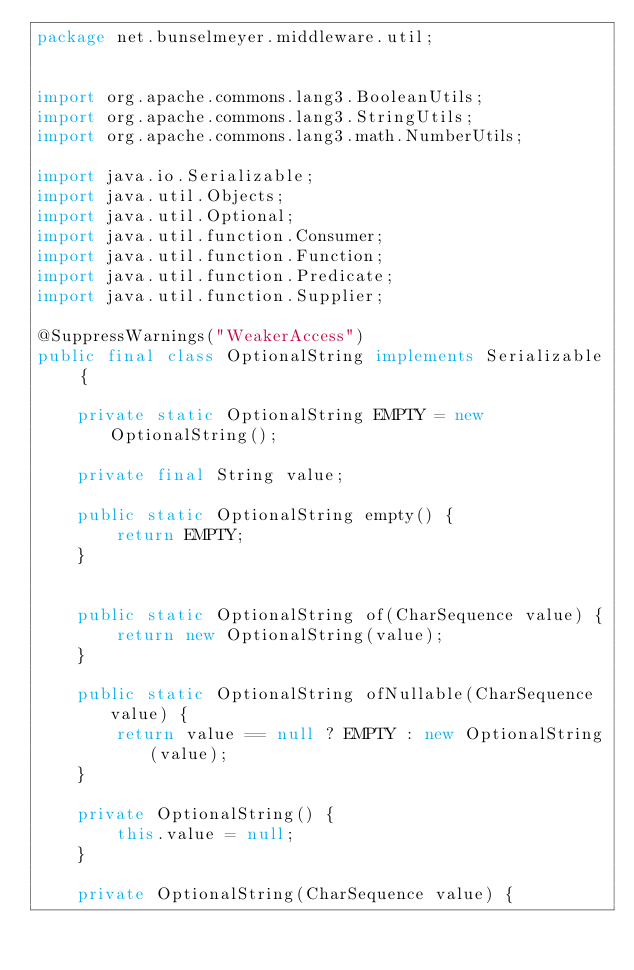<code> <loc_0><loc_0><loc_500><loc_500><_Java_>package net.bunselmeyer.middleware.util;


import org.apache.commons.lang3.BooleanUtils;
import org.apache.commons.lang3.StringUtils;
import org.apache.commons.lang3.math.NumberUtils;

import java.io.Serializable;
import java.util.Objects;
import java.util.Optional;
import java.util.function.Consumer;
import java.util.function.Function;
import java.util.function.Predicate;
import java.util.function.Supplier;

@SuppressWarnings("WeakerAccess")
public final class OptionalString implements Serializable {

    private static OptionalString EMPTY = new OptionalString();

    private final String value;

    public static OptionalString empty() {
        return EMPTY;
    }


    public static OptionalString of(CharSequence value) {
        return new OptionalString(value);
    }

    public static OptionalString ofNullable(CharSequence value) {
        return value == null ? EMPTY : new OptionalString(value);
    }

    private OptionalString() {
        this.value = null;
    }

    private OptionalString(CharSequence value) {</code> 